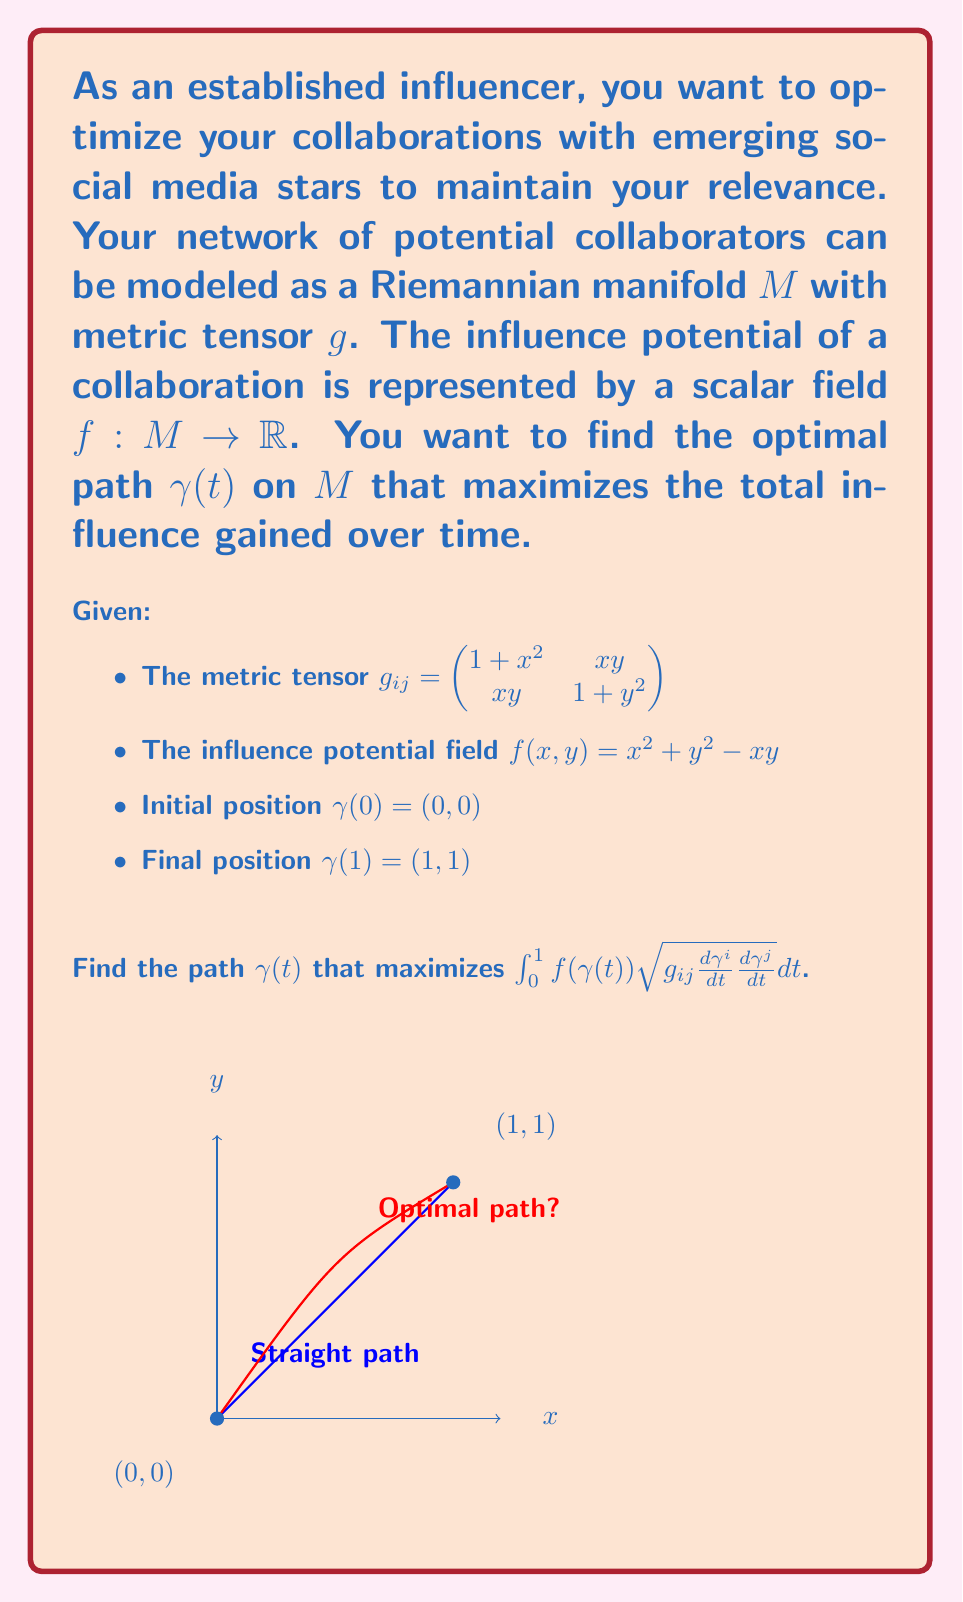Give your solution to this math problem. To solve this problem, we need to use the Euler-Lagrange equation from the calculus of variations on a Riemannian manifold. The steps are as follows:

1) The Lagrangian for this problem is:
   $$L(\gamma, \dot{\gamma}) = f(\gamma) \sqrt{g_{ij}\dot{\gamma}^i\dot{\gamma}^j}$$

2) The Euler-Lagrange equation on a Riemannian manifold is:
   $$\frac{d}{dt}\left(\frac{\partial L}{\partial \dot{\gamma}^k}\right) - \frac{\partial L}{\partial \gamma^k} + \Gamma^i_{jk}\frac{\partial L}{\partial \dot{\gamma}^i}\dot{\gamma}^j = 0$$
   where $\Gamma^i_{jk}$ are the Christoffel symbols.

3) Calculate the partial derivatives:
   $$\frac{\partial L}{\partial \dot{\gamma}^k} = \frac{f(\gamma)g_{kj}\dot{\gamma}^j}{\sqrt{g_{ij}\dot{\gamma}^i\dot{\gamma}^j}}$$
   $$\frac{\partial L}{\partial \gamma^k} = \frac{\partial f}{\partial \gamma^k}\sqrt{g_{ij}\dot{\gamma}^i\dot{\gamma}^j} + \frac{1}{2}f(\gamma)\frac{\partial g_{ij}}{\partial \gamma^k}\frac{\dot{\gamma}^i\dot{\gamma}^j}{\sqrt{g_{ij}\dot{\gamma}^i\dot{\gamma}^j}}$$

4) Substitute these into the Euler-Lagrange equation and simplify. This results in a system of second-order differential equations.

5) Due to the complexity of the resulting equations, a closed-form solution is not feasible. Numerical methods such as the shooting method or finite difference method would be used to solve this boundary value problem.

6) The solution would give us the optimal path $\gamma(t) = (x(t), y(t))$ that maximizes the influence potential integral.

7) This path represents the optimal strategy for collaborating with emerging stars over time, balancing between immediate influence gain and network position improvement.
Answer: The optimal path $\gamma(t)$ is a curved trajectory from (0,0) to (1,1), solved numerically using the derived Euler-Lagrange equations. 